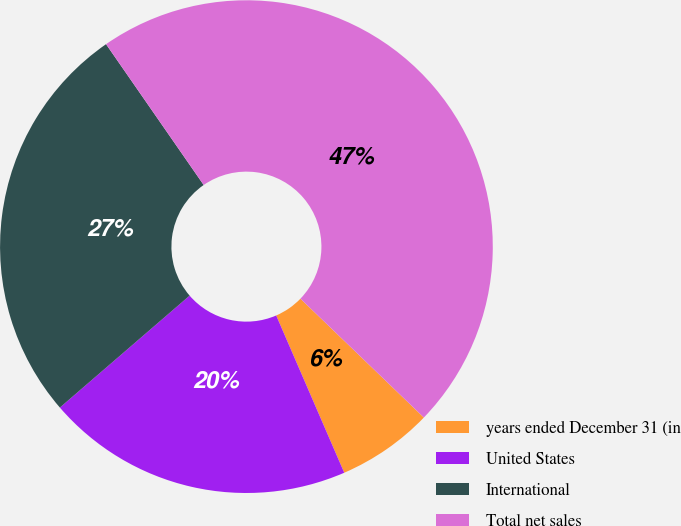Convert chart to OTSL. <chart><loc_0><loc_0><loc_500><loc_500><pie_chart><fcel>years ended December 31 (in<fcel>United States<fcel>International<fcel>Total net sales<nl><fcel>6.3%<fcel>20.17%<fcel>26.68%<fcel>46.85%<nl></chart> 